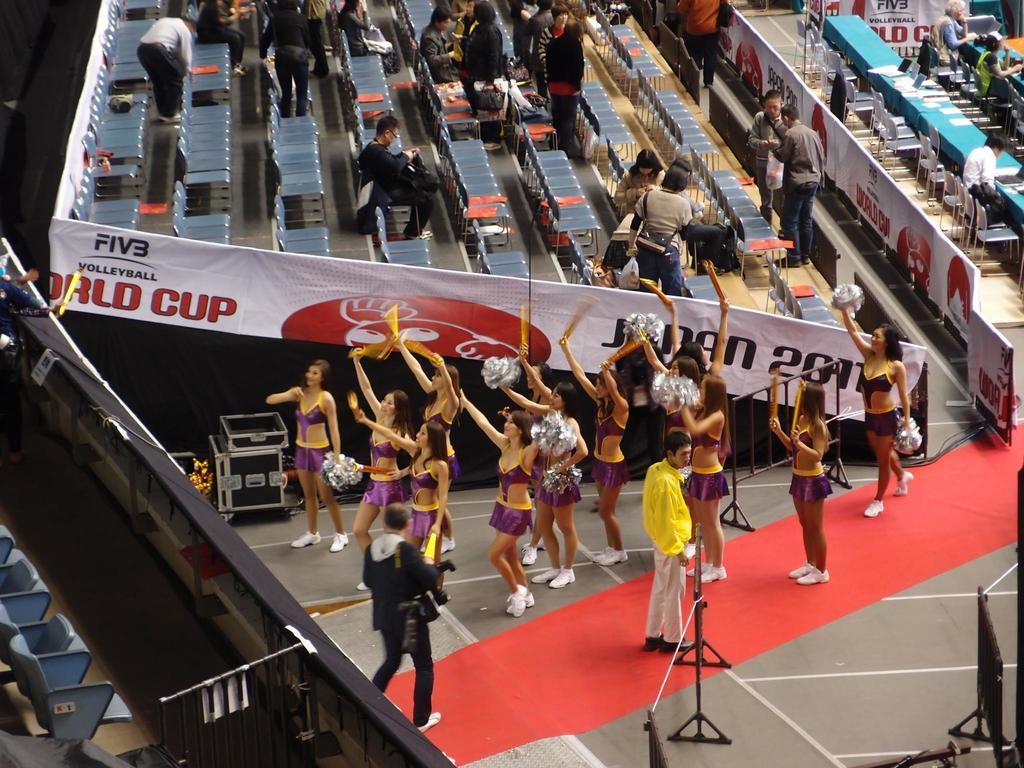Can you describe this image briefly? In this picture there are group of people standing and holding the objects and there is a person holding the camera and he is walking. In the foreground there is a person and there is a stand. On the left side of the image there are chairs. At the back there are group of people standing and there are group of people sitting. There are devices and papers on the table and the table is covered with blue color cloth and there are hoardings. At the bottom there is a red carpet and there are devices and wires. 